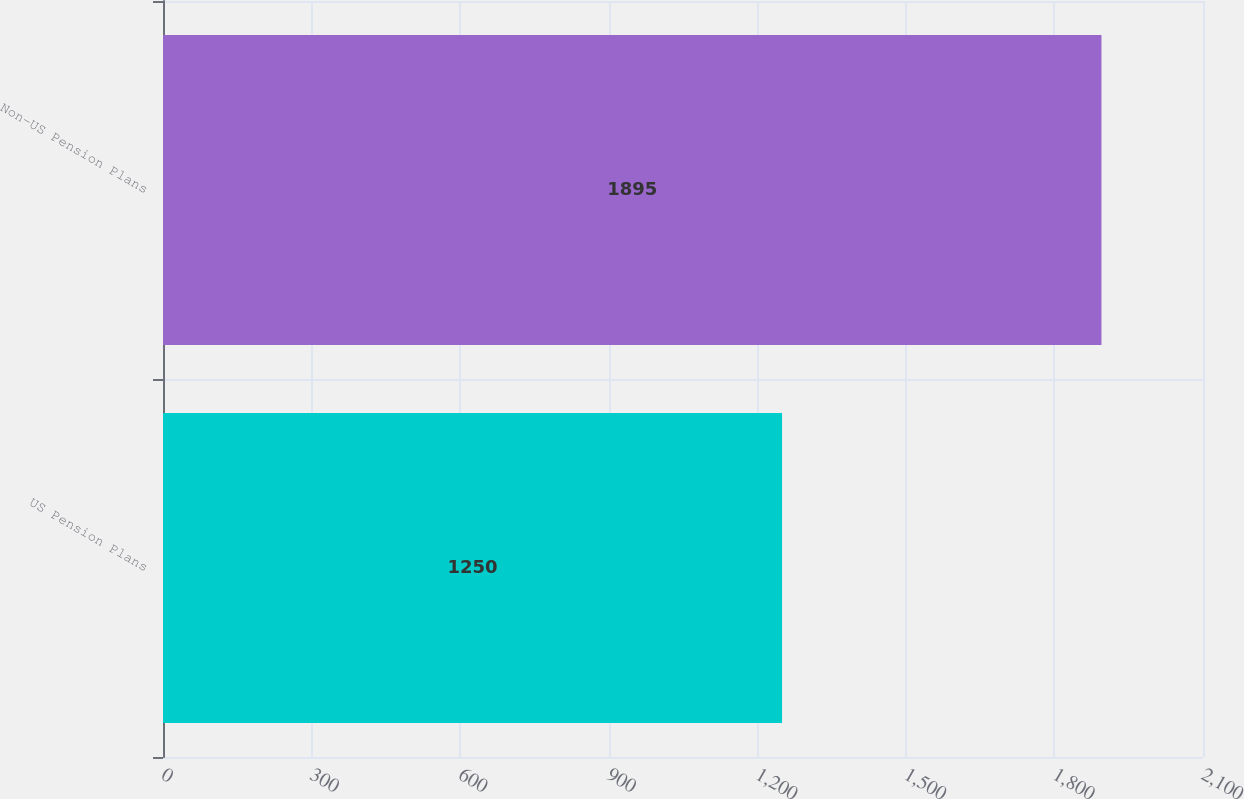Convert chart to OTSL. <chart><loc_0><loc_0><loc_500><loc_500><bar_chart><fcel>US Pension Plans<fcel>Non-US Pension Plans<nl><fcel>1250<fcel>1895<nl></chart> 